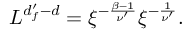Convert formula to latex. <formula><loc_0><loc_0><loc_500><loc_500>\begin{array} { r } { L ^ { d _ { f } ^ { \prime } - d } = \xi ^ { - \frac { \beta - 1 } { \nu ^ { \prime } } } \xi ^ { - \frac { 1 } { \nu ^ { \prime } } } . } \end{array}</formula> 